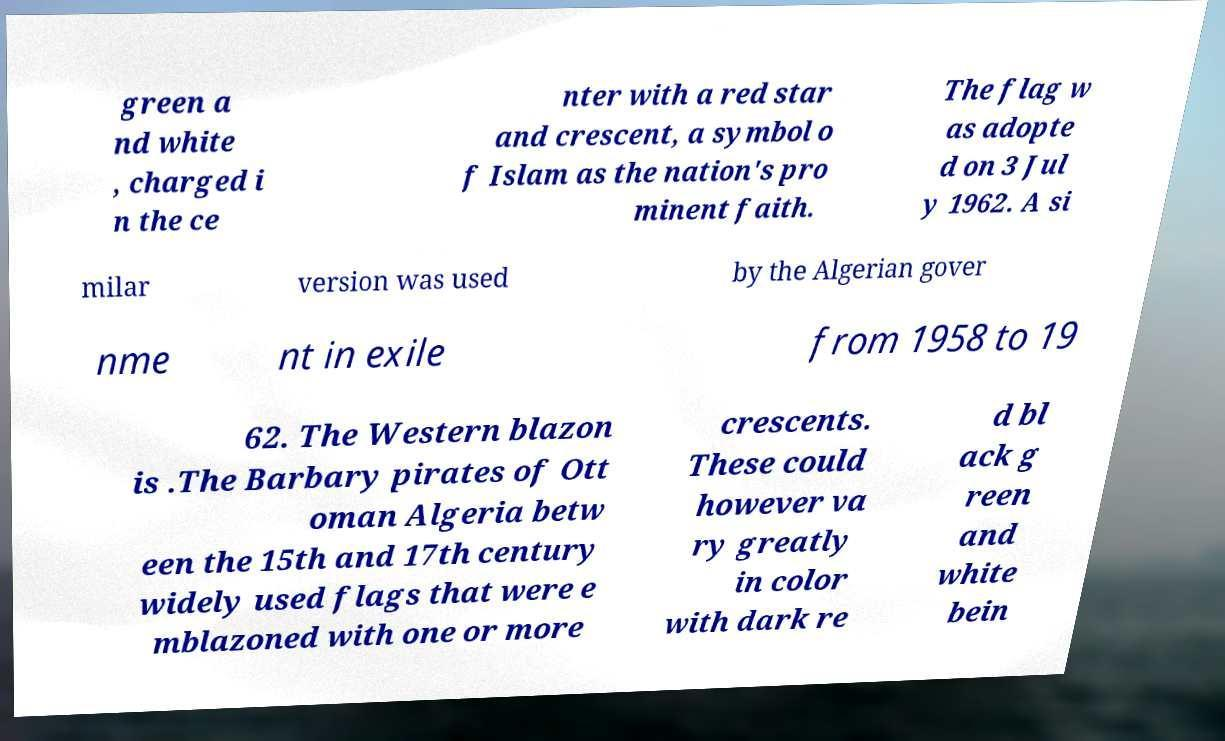For documentation purposes, I need the text within this image transcribed. Could you provide that? green a nd white , charged i n the ce nter with a red star and crescent, a symbol o f Islam as the nation's pro minent faith. The flag w as adopte d on 3 Jul y 1962. A si milar version was used by the Algerian gover nme nt in exile from 1958 to 19 62. The Western blazon is .The Barbary pirates of Ott oman Algeria betw een the 15th and 17th century widely used flags that were e mblazoned with one or more crescents. These could however va ry greatly in color with dark re d bl ack g reen and white bein 